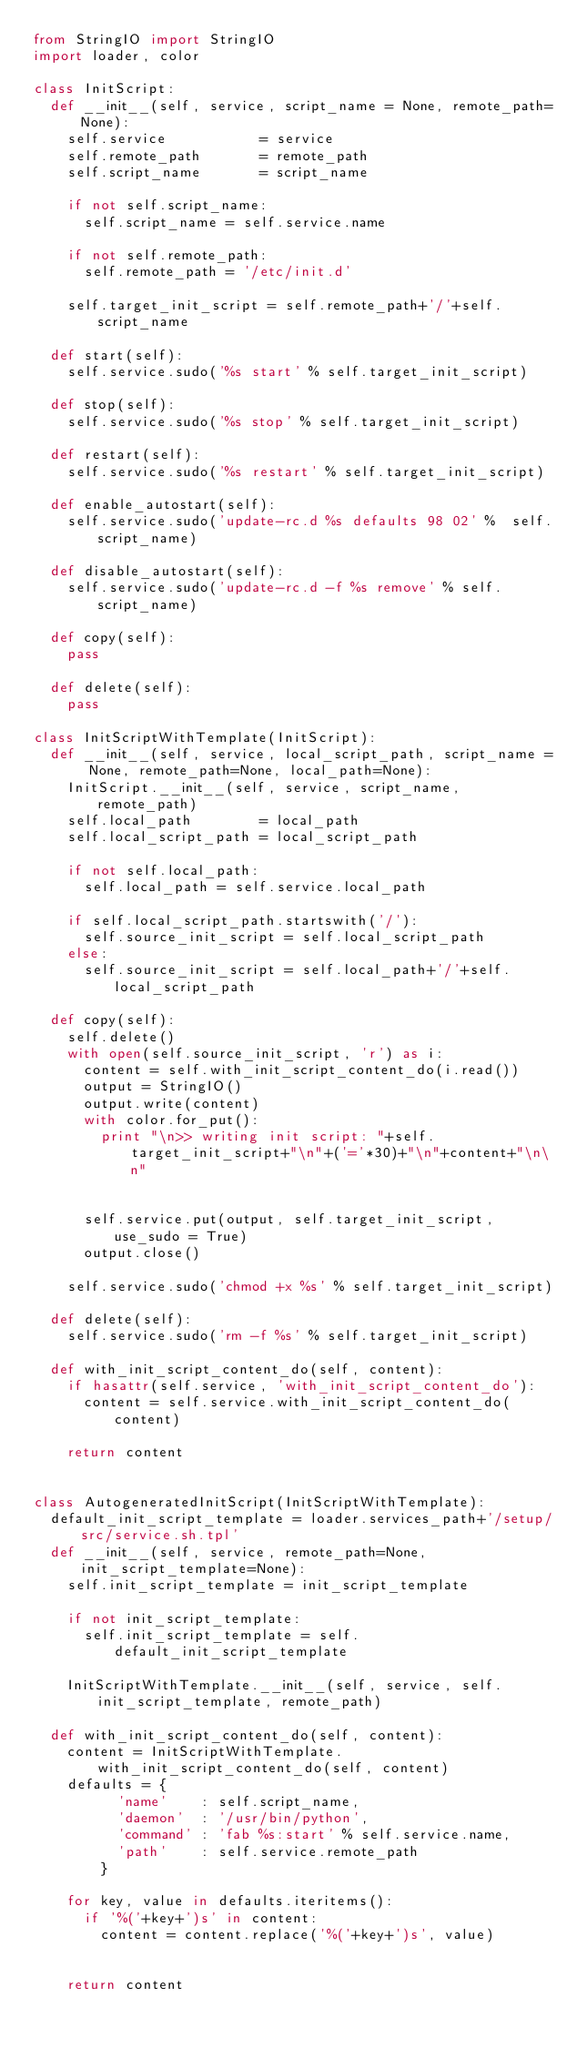Convert code to text. <code><loc_0><loc_0><loc_500><loc_500><_Python_>from StringIO import StringIO
import loader, color

class InitScript:
  def __init__(self, service, script_name = None, remote_path=None):
    self.service           = service
    self.remote_path       = remote_path
    self.script_name       = script_name

    if not self.script_name:
      self.script_name = self.service.name

    if not self.remote_path:
      self.remote_path = '/etc/init.d'

    self.target_init_script = self.remote_path+'/'+self.script_name

  def start(self):
    self.service.sudo('%s start' % self.target_init_script)

  def stop(self):
    self.service.sudo('%s stop' % self.target_init_script)

  def restart(self):
    self.service.sudo('%s restart' % self.target_init_script)

  def enable_autostart(self):
    self.service.sudo('update-rc.d %s defaults 98 02' %  self.script_name)

  def disable_autostart(self):
    self.service.sudo('update-rc.d -f %s remove' % self.script_name)

  def copy(self):
    pass

  def delete(self):
    pass

class InitScriptWithTemplate(InitScript):
  def __init__(self, service, local_script_path, script_name = None, remote_path=None, local_path=None):
    InitScript.__init__(self, service, script_name, remote_path)
    self.local_path        = local_path
    self.local_script_path = local_script_path

    if not self.local_path:
      self.local_path = self.service.local_path

    if self.local_script_path.startswith('/'):
      self.source_init_script = self.local_script_path
    else:
      self.source_init_script = self.local_path+'/'+self.local_script_path

  def copy(self):
    self.delete()
    with open(self.source_init_script, 'r') as i:
      content = self.with_init_script_content_do(i.read())
      output = StringIO()
      output.write(content)
      with color.for_put():
        print "\n>> writing init script: "+self.target_init_script+"\n"+('='*30)+"\n"+content+"\n\n"


      self.service.put(output, self.target_init_script, use_sudo = True)
      output.close()

    self.service.sudo('chmod +x %s' % self.target_init_script)

  def delete(self):
    self.service.sudo('rm -f %s' % self.target_init_script)

  def with_init_script_content_do(self, content):
    if hasattr(self.service, 'with_init_script_content_do'):
      content = self.service.with_init_script_content_do(content)

    return content


class AutogeneratedInitScript(InitScriptWithTemplate):
  default_init_script_template = loader.services_path+'/setup/src/service.sh.tpl'
  def __init__(self, service, remote_path=None, init_script_template=None):
    self.init_script_template = init_script_template

    if not init_script_template:
      self.init_script_template = self.default_init_script_template

    InitScriptWithTemplate.__init__(self, service, self.init_script_template, remote_path)

  def with_init_script_content_do(self, content):
    content = InitScriptWithTemplate.with_init_script_content_do(self, content)
    defaults = {
          'name'    : self.script_name,
          'daemon'  : '/usr/bin/python',
          'command' : 'fab %s:start' % self.service.name,
          'path'    : self.service.remote_path
        }

    for key, value in defaults.iteritems():
      if '%('+key+')s' in content:
        content = content.replace('%('+key+')s', value)


    return content
</code> 